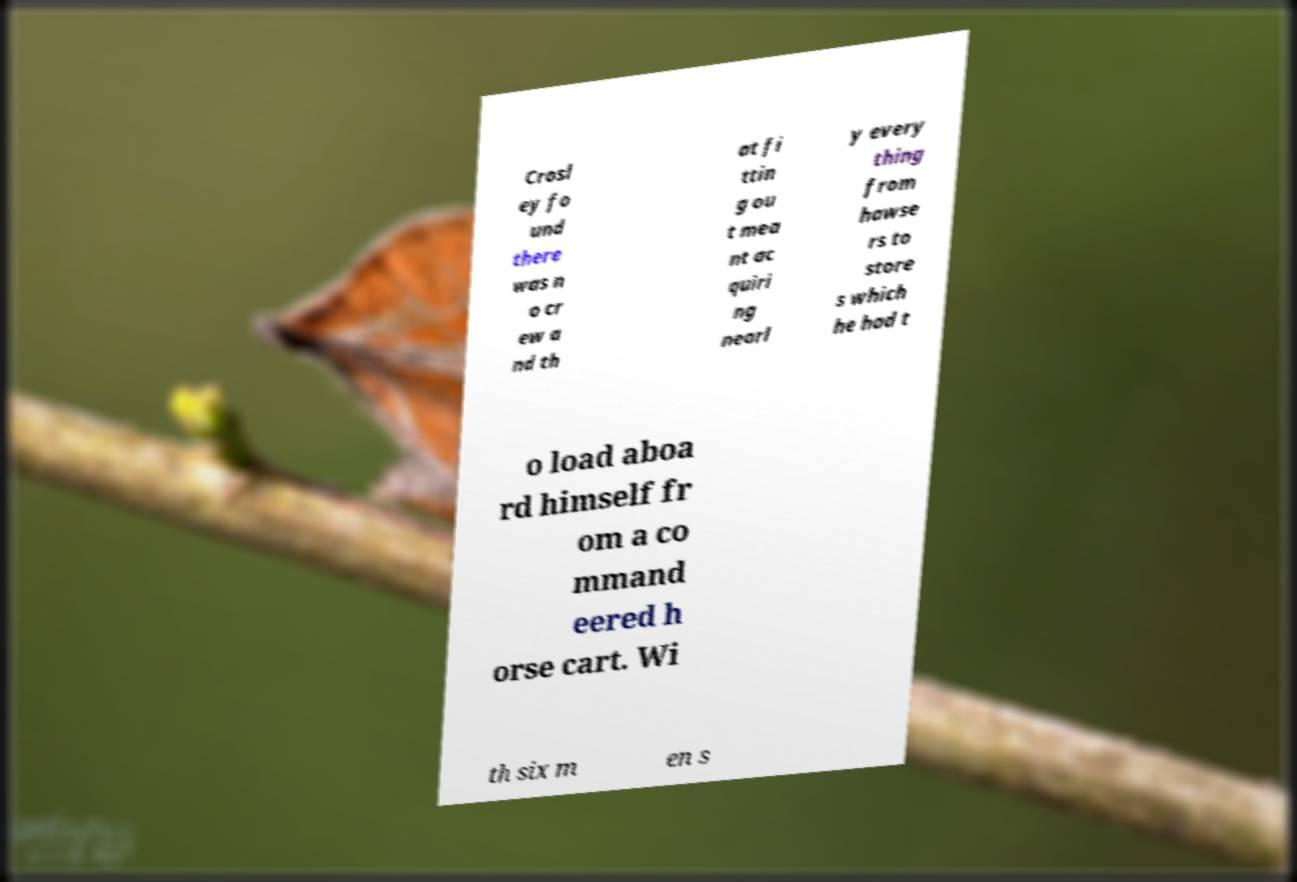Can you accurately transcribe the text from the provided image for me? Crosl ey fo und there was n o cr ew a nd th at fi ttin g ou t mea nt ac quiri ng nearl y every thing from hawse rs to store s which he had t o load aboa rd himself fr om a co mmand eered h orse cart. Wi th six m en s 